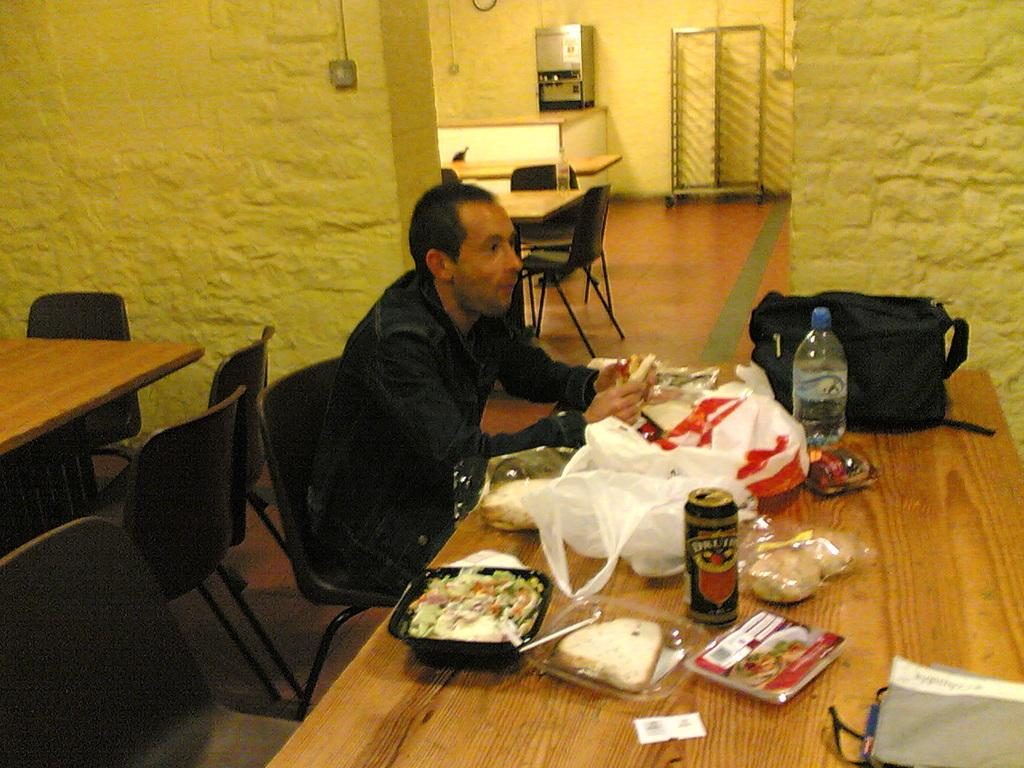What color is the dress that the person is wearing in the image? The person is wearing a black dress. What is the person sitting on in the image? The person is sitting in a black chair. What is the person doing in the image? The person is eating. What is present in front of the person in the image? There is a table in front of the person. What can be found on the table in the image? The table has eatables on it. What color are the walls in the image? The walls are yellow in color. How many units of angle can be seen in the image? There are no units of angle present in the image. What type of glove is the person wearing in the image? The person is not wearing any gloves in the image. 